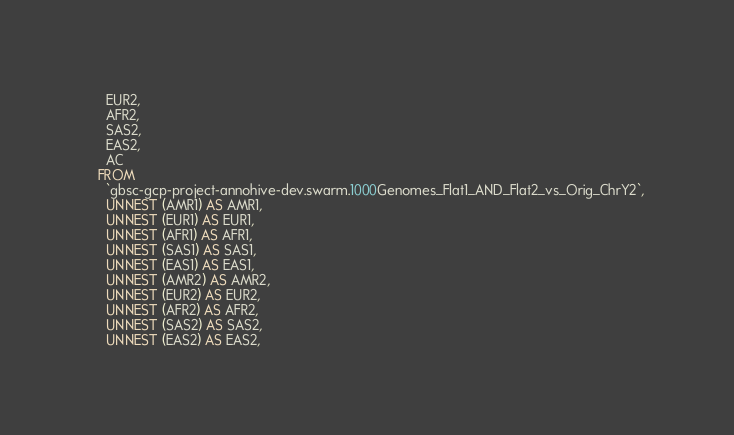<code> <loc_0><loc_0><loc_500><loc_500><_SQL_>    EUR2,
    AFR2,
    SAS2,
    EAS2,
    AC
  FROM
    `gbsc-gcp-project-annohive-dev.swarm.1000Genomes_Flat1_AND_Flat2_vs_Orig_ChrY2`,
    UNNEST (AMR1) AS AMR1,
    UNNEST (EUR1) AS EUR1,
    UNNEST (AFR1) AS AFR1,
    UNNEST (SAS1) AS SAS1,
    UNNEST (EAS1) AS EAS1,
    UNNEST (AMR2) AS AMR2,
    UNNEST (EUR2) AS EUR2,
    UNNEST (AFR2) AS AFR2,
    UNNEST (SAS2) AS SAS2,
    UNNEST (EAS2) AS EAS2,</code> 